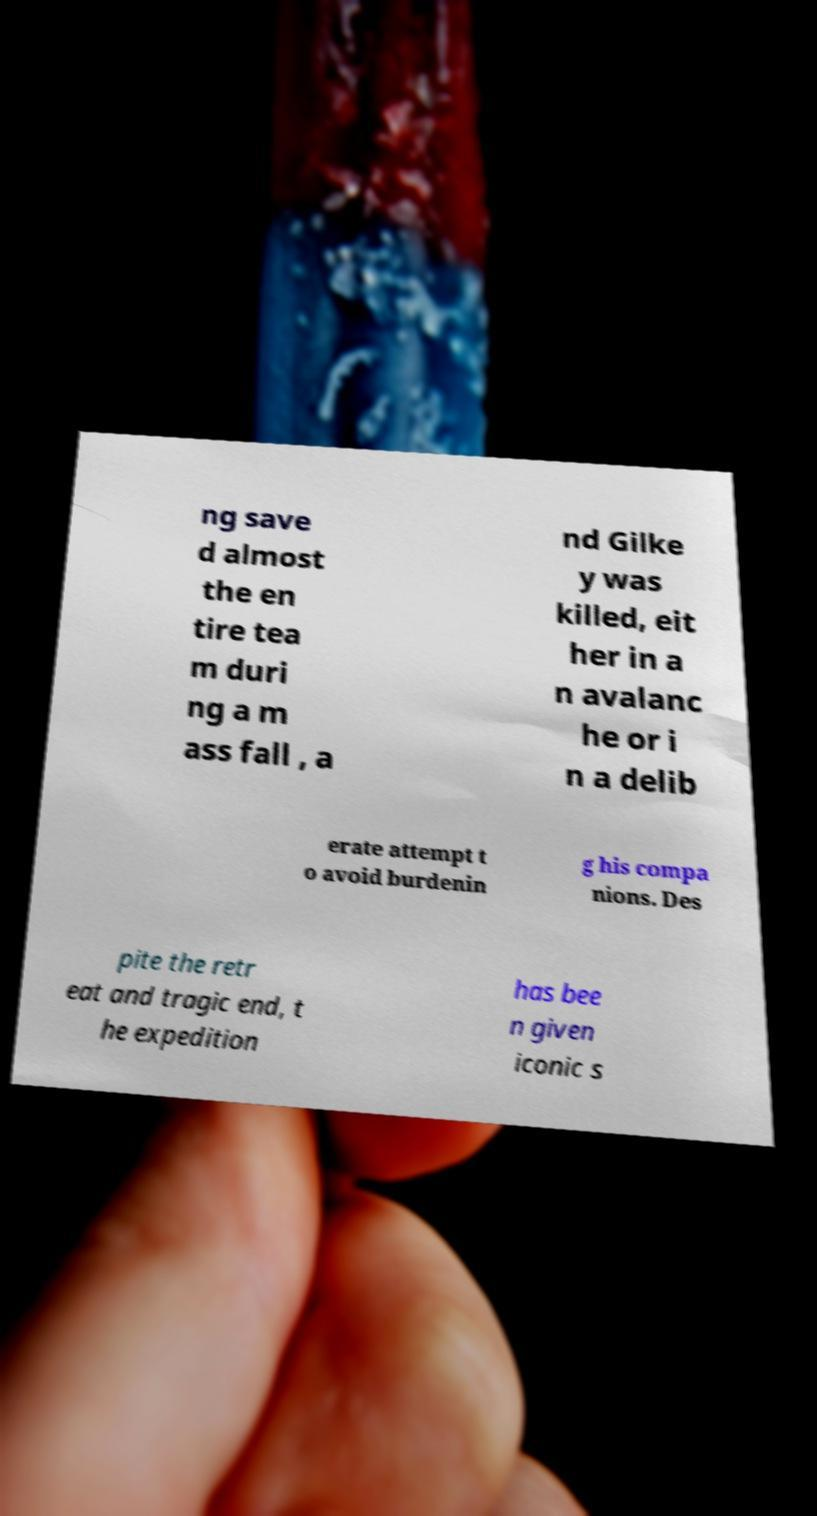I need the written content from this picture converted into text. Can you do that? ng save d almost the en tire tea m duri ng a m ass fall , a nd Gilke y was killed, eit her in a n avalanc he or i n a delib erate attempt t o avoid burdenin g his compa nions. Des pite the retr eat and tragic end, t he expedition has bee n given iconic s 